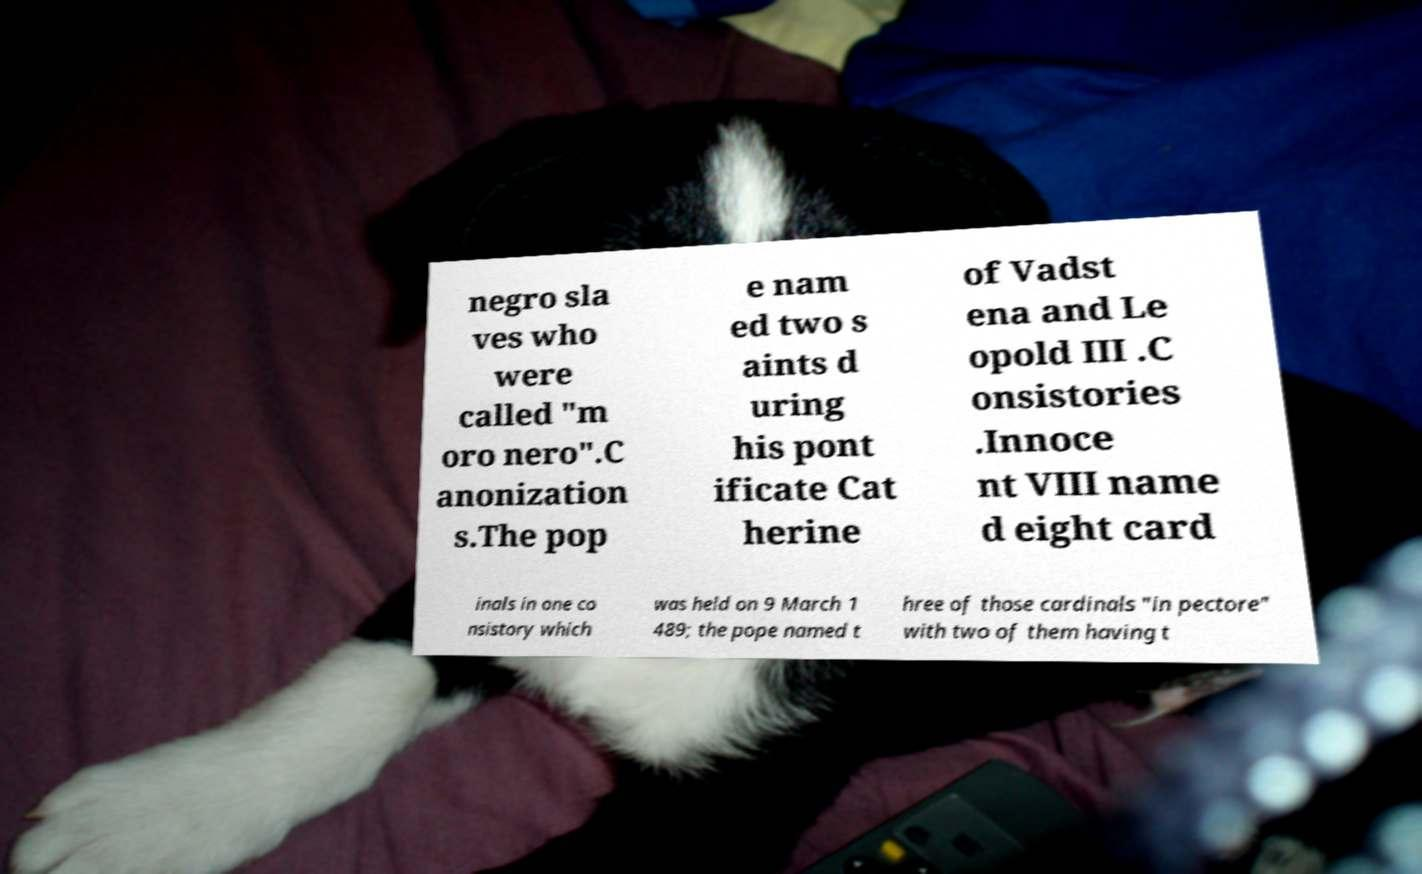For documentation purposes, I need the text within this image transcribed. Could you provide that? negro sla ves who were called "m oro nero".C anonization s.The pop e nam ed two s aints d uring his pont ificate Cat herine of Vadst ena and Le opold III .C onsistories .Innoce nt VIII name d eight card inals in one co nsistory which was held on 9 March 1 489; the pope named t hree of those cardinals "in pectore" with two of them having t 